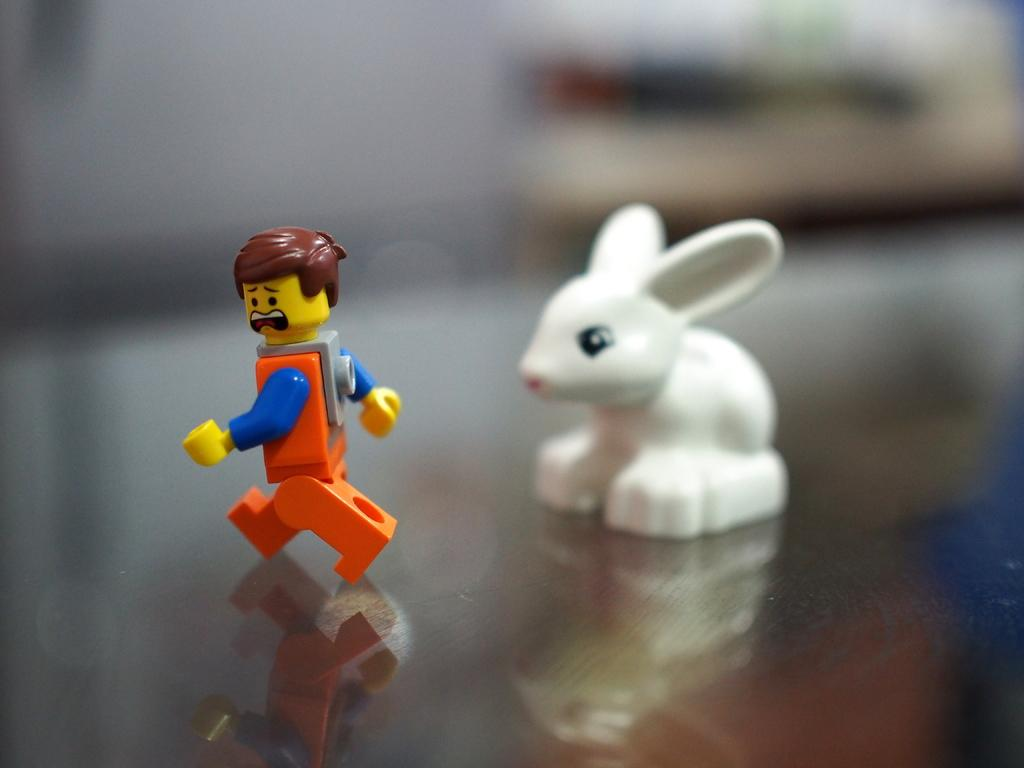What type of objects can be seen in the image? There are toys in the image. What time of day is it in the image, and are there any babies present? The time of day and presence of babies cannot be determined from the image, as it only shows toys. 